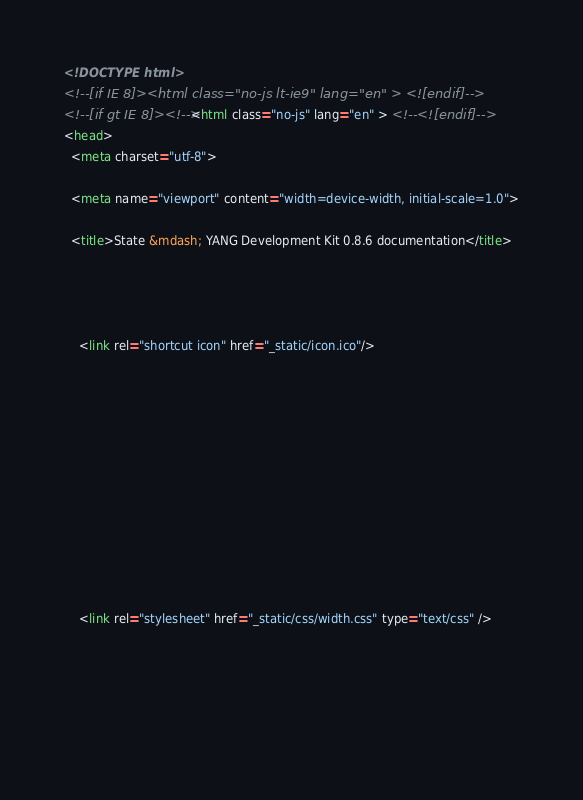<code> <loc_0><loc_0><loc_500><loc_500><_HTML_>

<!DOCTYPE html>
<!--[if IE 8]><html class="no-js lt-ie9" lang="en" > <![endif]-->
<!--[if gt IE 8]><!--> <html class="no-js" lang="en" > <!--<![endif]-->
<head>
  <meta charset="utf-8">
  
  <meta name="viewport" content="width=device-width, initial-scale=1.0">
  
  <title>State &mdash; YANG Development Kit 0.8.6 documentation</title>
  

  
  
    <link rel="shortcut icon" href="_static/icon.ico"/>
  

  

  
  
    

  

  
  
    <link rel="stylesheet" href="_static/css/width.css" type="text/css" />
  

  

  </code> 